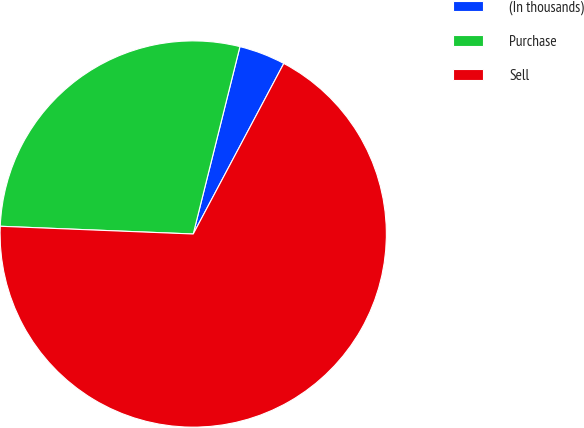<chart> <loc_0><loc_0><loc_500><loc_500><pie_chart><fcel>(In thousands)<fcel>Purchase<fcel>Sell<nl><fcel>3.88%<fcel>28.25%<fcel>67.87%<nl></chart> 